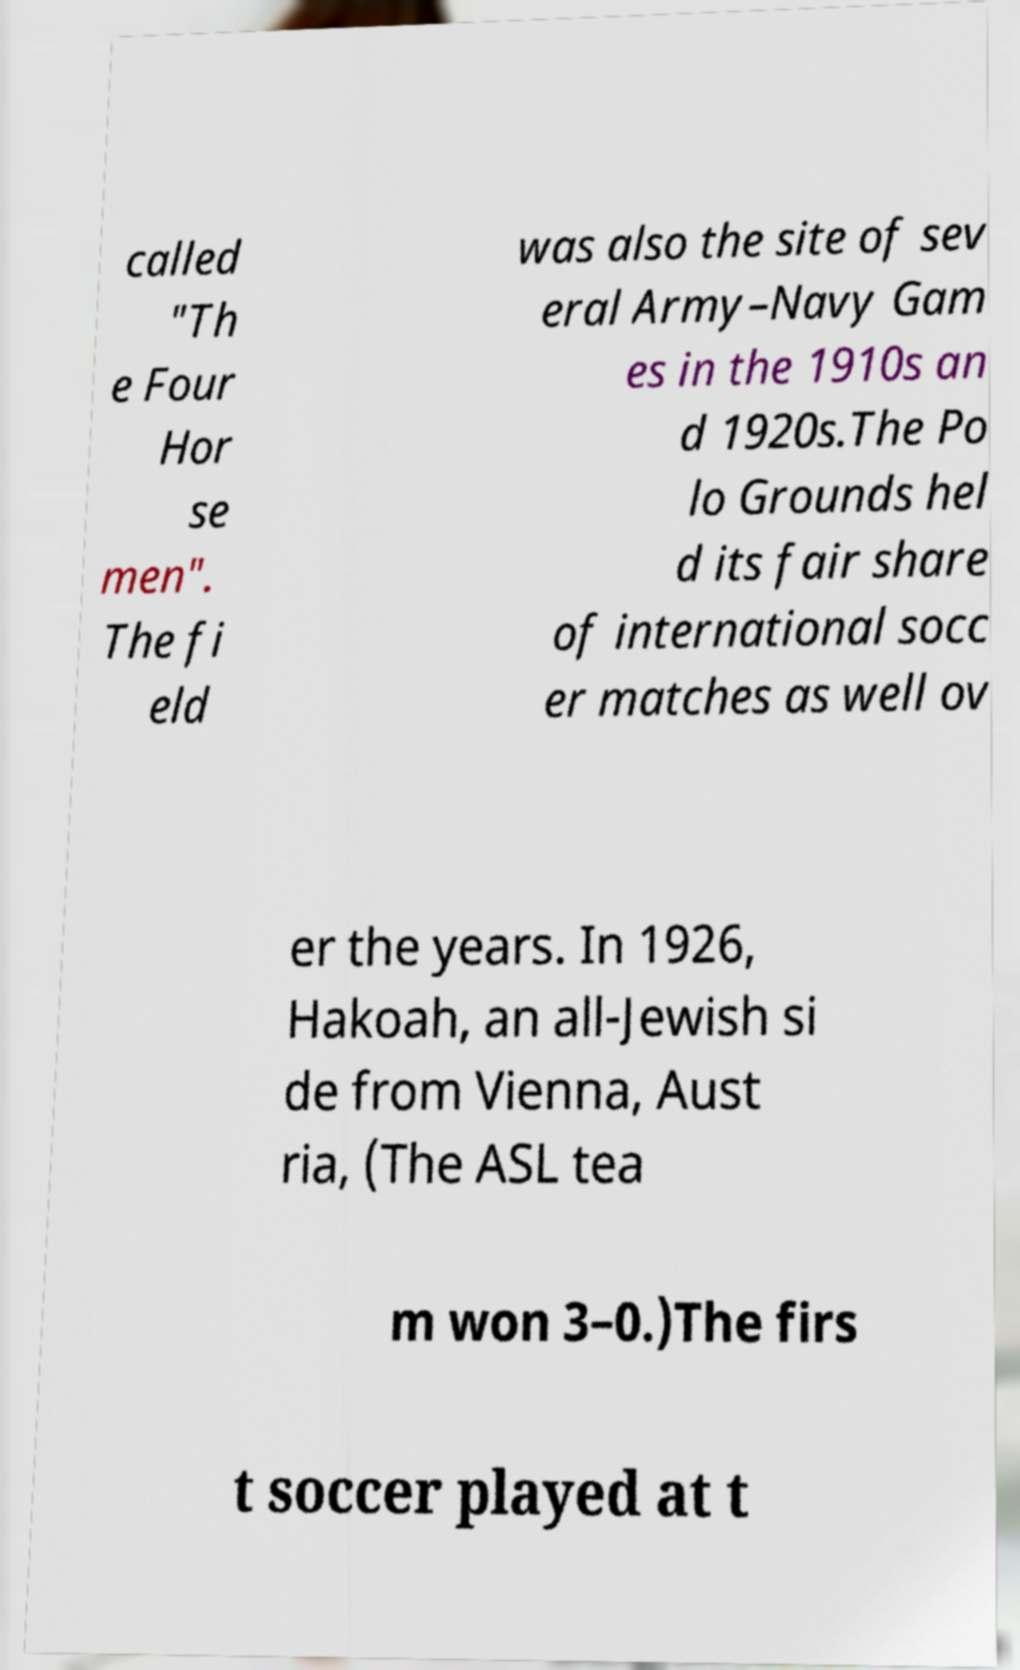What can you tell about the 'Four Horsemen' mentioned in this text? The 'Four Horsemen' refers to the four legendary football players from the University of Notre Dame under coach Knute Rockne during the 1924 season. Their names were Harry Stuhldreher, Jim Crowley, Don Miller, and Elmer Layden. They gained immense fame after a sports writer, Grantland Rice, described them as the 'Four Horsemen' of the Apocalypse due to their dominant play. 